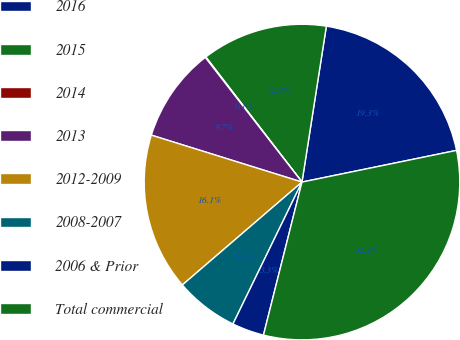Convert chart. <chart><loc_0><loc_0><loc_500><loc_500><pie_chart><fcel>2016<fcel>2015<fcel>2014<fcel>2013<fcel>2012-2009<fcel>2008-2007<fcel>2006 & Prior<fcel>Total commercial<nl><fcel>19.31%<fcel>12.9%<fcel>0.07%<fcel>9.69%<fcel>16.11%<fcel>6.49%<fcel>3.28%<fcel>32.14%<nl></chart> 